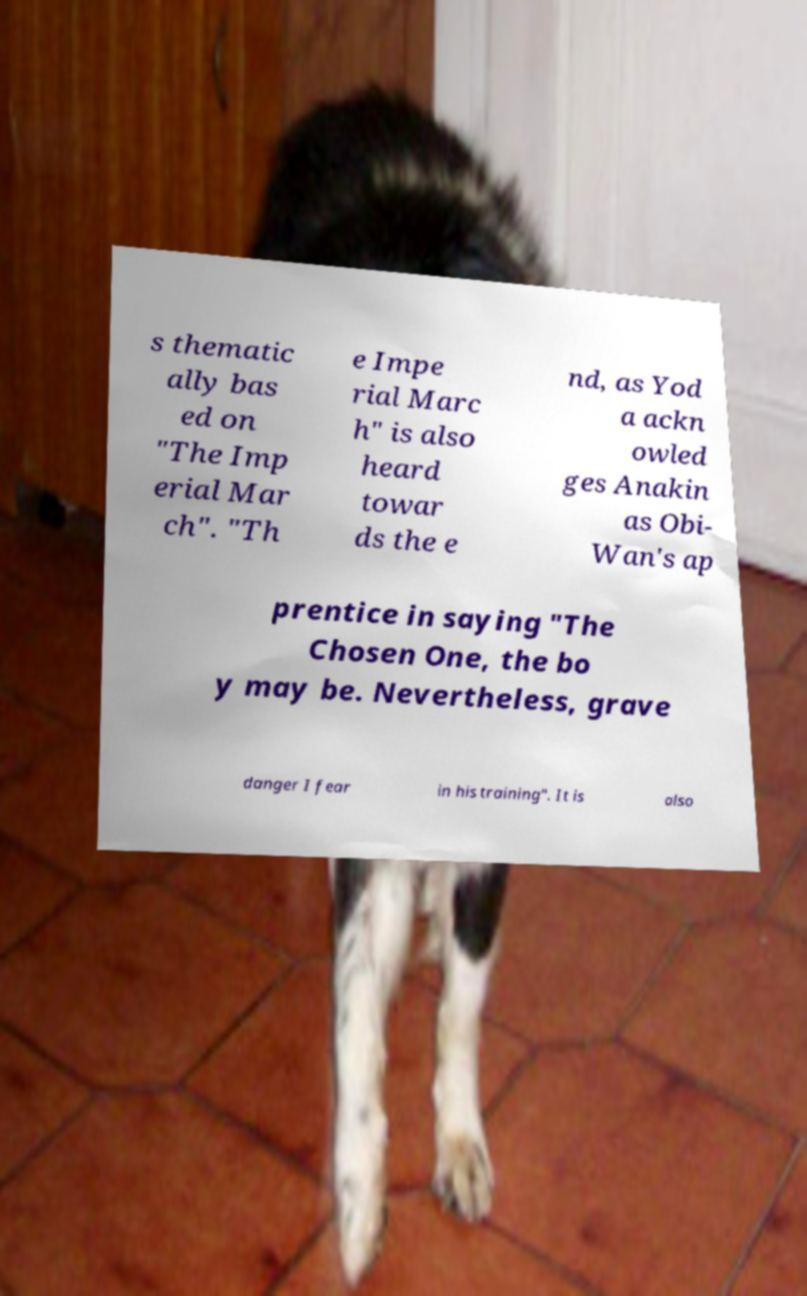For documentation purposes, I need the text within this image transcribed. Could you provide that? s thematic ally bas ed on "The Imp erial Mar ch". "Th e Impe rial Marc h" is also heard towar ds the e nd, as Yod a ackn owled ges Anakin as Obi- Wan's ap prentice in saying "The Chosen One, the bo y may be. Nevertheless, grave danger I fear in his training". It is also 